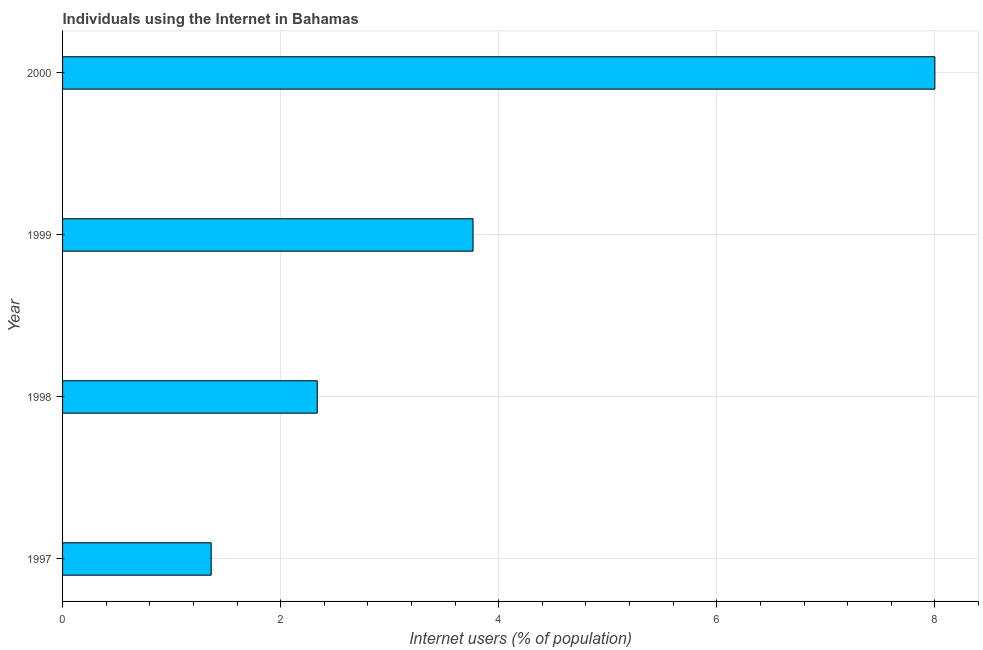What is the title of the graph?
Your answer should be very brief. Individuals using the Internet in Bahamas. What is the label or title of the X-axis?
Provide a short and direct response. Internet users (% of population). What is the label or title of the Y-axis?
Your answer should be compact. Year. What is the number of internet users in 2000?
Make the answer very short. 8. Across all years, what is the minimum number of internet users?
Your response must be concise. 1.36. In which year was the number of internet users maximum?
Give a very brief answer. 2000. What is the sum of the number of internet users?
Make the answer very short. 15.46. What is the difference between the number of internet users in 1997 and 1999?
Make the answer very short. -2.4. What is the average number of internet users per year?
Make the answer very short. 3.87. What is the median number of internet users?
Offer a terse response. 3.05. What is the ratio of the number of internet users in 1997 to that in 1998?
Make the answer very short. 0.58. Is the number of internet users in 1998 less than that in 1999?
Make the answer very short. Yes. Is the difference between the number of internet users in 1997 and 2000 greater than the difference between any two years?
Make the answer very short. Yes. What is the difference between the highest and the second highest number of internet users?
Make the answer very short. 4.24. Is the sum of the number of internet users in 1997 and 1999 greater than the maximum number of internet users across all years?
Offer a very short reply. No. What is the difference between the highest and the lowest number of internet users?
Keep it short and to the point. 6.64. In how many years, is the number of internet users greater than the average number of internet users taken over all years?
Your answer should be very brief. 1. How many bars are there?
Give a very brief answer. 4. How many years are there in the graph?
Your answer should be compact. 4. Are the values on the major ticks of X-axis written in scientific E-notation?
Your answer should be compact. No. What is the Internet users (% of population) in 1997?
Your response must be concise. 1.36. What is the Internet users (% of population) of 1998?
Your answer should be compact. 2.34. What is the Internet users (% of population) in 1999?
Provide a succinct answer. 3.76. What is the difference between the Internet users (% of population) in 1997 and 1998?
Keep it short and to the point. -0.97. What is the difference between the Internet users (% of population) in 1997 and 1999?
Your answer should be compact. -2.4. What is the difference between the Internet users (% of population) in 1997 and 2000?
Your answer should be compact. -6.64. What is the difference between the Internet users (% of population) in 1998 and 1999?
Make the answer very short. -1.43. What is the difference between the Internet users (% of population) in 1998 and 2000?
Give a very brief answer. -5.66. What is the difference between the Internet users (% of population) in 1999 and 2000?
Your answer should be compact. -4.24. What is the ratio of the Internet users (% of population) in 1997 to that in 1998?
Provide a succinct answer. 0.58. What is the ratio of the Internet users (% of population) in 1997 to that in 1999?
Your answer should be very brief. 0.36. What is the ratio of the Internet users (% of population) in 1997 to that in 2000?
Ensure brevity in your answer.  0.17. What is the ratio of the Internet users (% of population) in 1998 to that in 1999?
Provide a short and direct response. 0.62. What is the ratio of the Internet users (% of population) in 1998 to that in 2000?
Keep it short and to the point. 0.29. What is the ratio of the Internet users (% of population) in 1999 to that in 2000?
Provide a short and direct response. 0.47. 